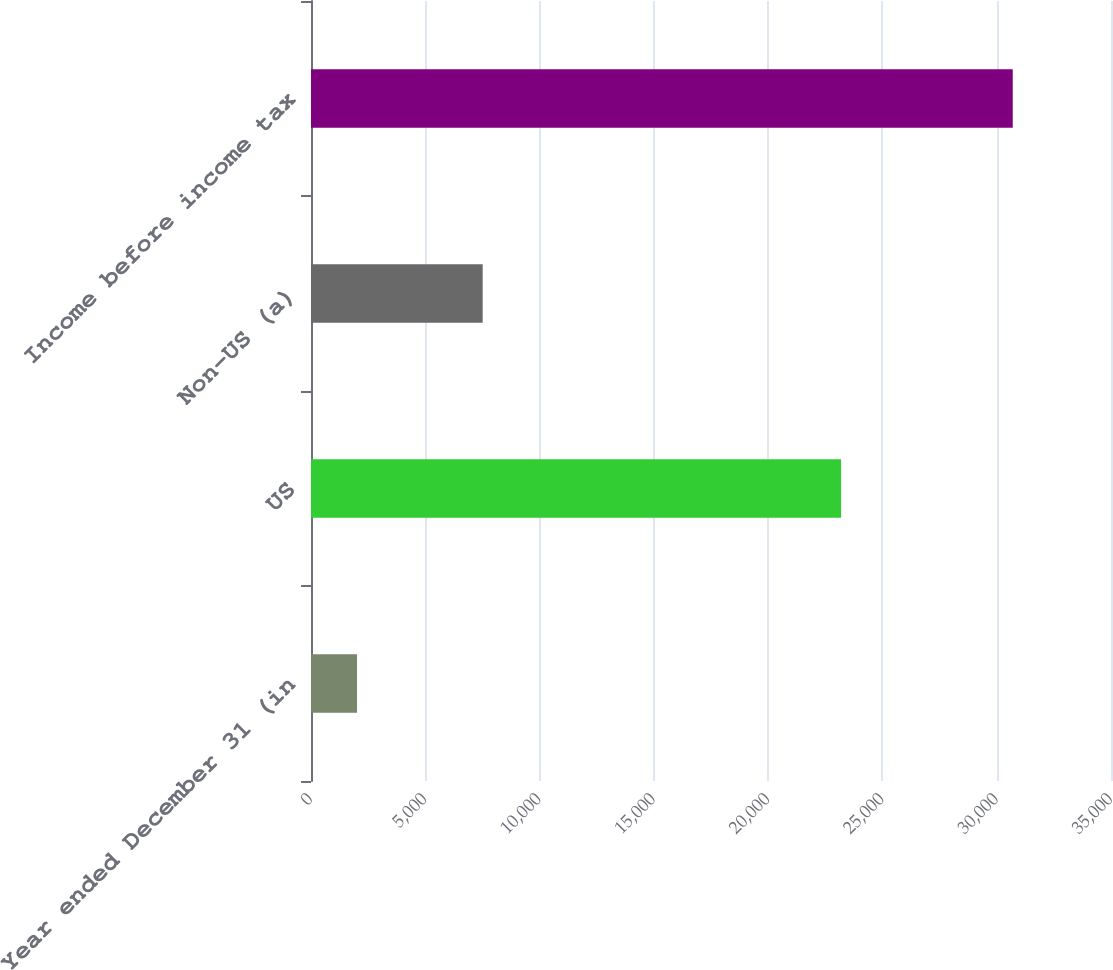Convert chart to OTSL. <chart><loc_0><loc_0><loc_500><loc_500><bar_chart><fcel>Year ended December 31 (in<fcel>US<fcel>Non-US (a)<fcel>Income before income tax<nl><fcel>2015<fcel>23191<fcel>7511<fcel>30702<nl></chart> 